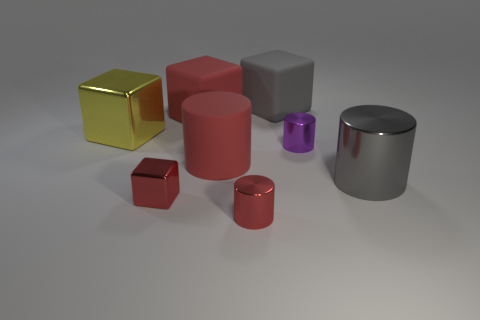What is the shape of the big gray object that is behind the red cylinder that is behind the tiny red metal cylinder?
Provide a succinct answer. Cube. Is there anything else that has the same shape as the yellow object?
Keep it short and to the point. Yes. Are there more cylinders in front of the gray shiny cylinder than blue metallic blocks?
Offer a very short reply. Yes. There is a large thing behind the red matte cube; what number of gray matte cubes are behind it?
Give a very brief answer. 0. What shape is the large metal object that is left of the tiny metallic cube left of the red cube on the right side of the tiny red block?
Provide a short and direct response. Cube. What size is the purple metallic cylinder?
Offer a very short reply. Small. Are there any purple cylinders made of the same material as the tiny red cylinder?
Make the answer very short. Yes. What is the size of the gray thing that is the same shape as the big yellow metal thing?
Your answer should be very brief. Large. Is the number of matte blocks to the left of the large red cylinder the same as the number of red rubber objects?
Your answer should be compact. No. There is a large shiny object on the left side of the tiny red block; is its shape the same as the large gray rubber thing?
Provide a short and direct response. Yes. 